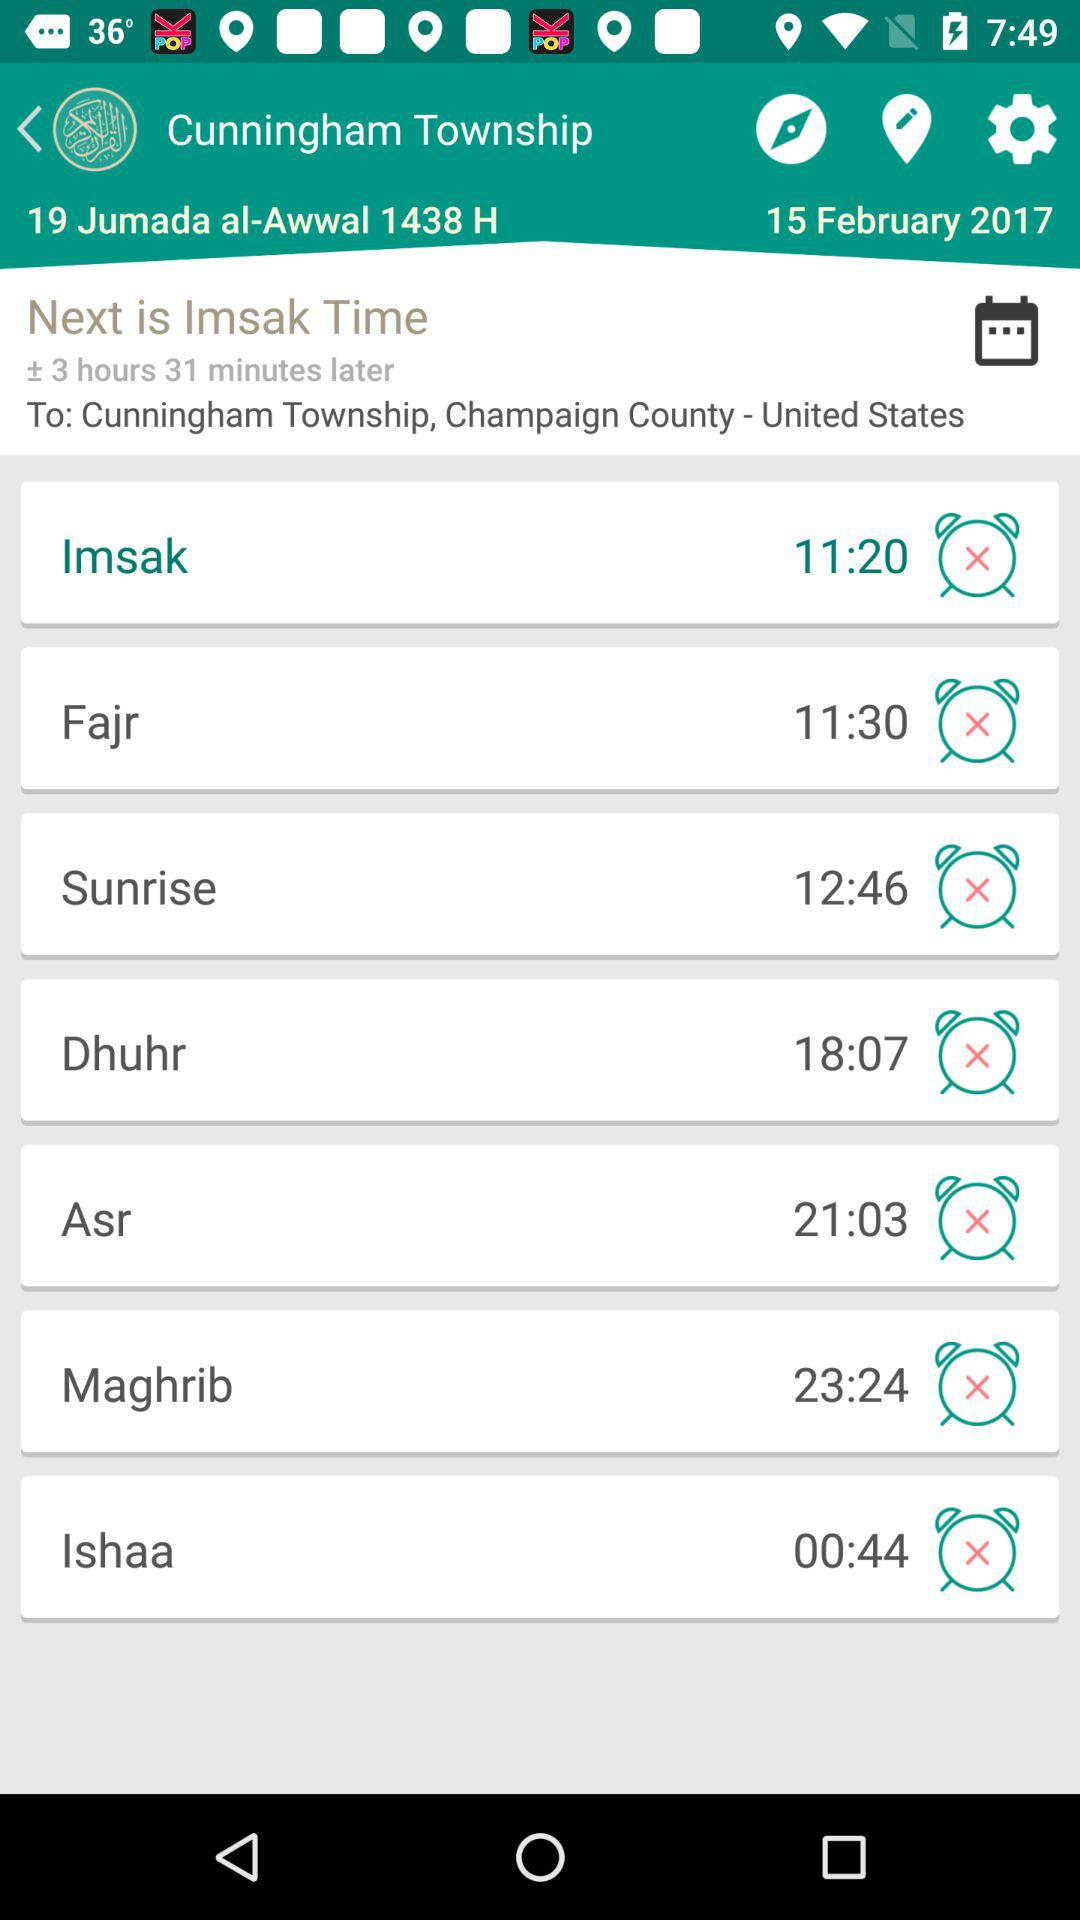What is the date for "19 Jumada al-Awwal"? The date is February 15, 2017. 